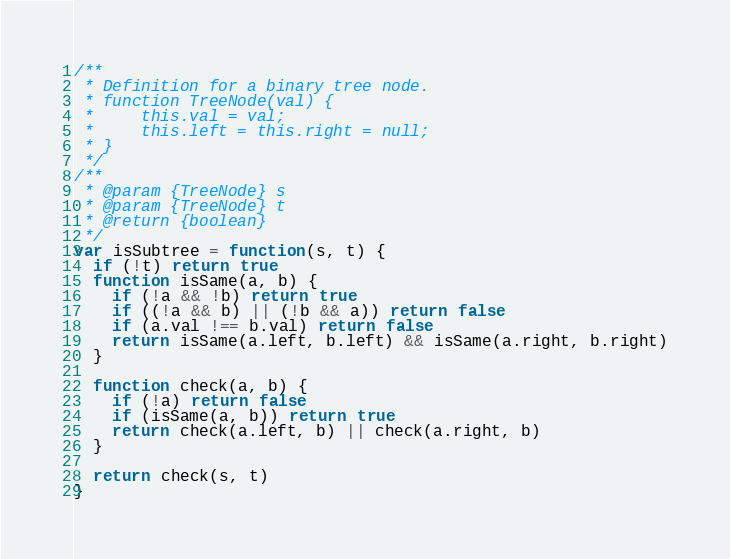Convert code to text. <code><loc_0><loc_0><loc_500><loc_500><_JavaScript_>/**
 * Definition for a binary tree node.
 * function TreeNode(val) {
 *     this.val = val;
 *     this.left = this.right = null;
 * }
 */
/**
 * @param {TreeNode} s
 * @param {TreeNode} t
 * @return {boolean}
 */
var isSubtree = function(s, t) {
  if (!t) return true
  function isSame(a, b) {
    if (!a && !b) return true
    if ((!a && b) || (!b && a)) return false
    if (a.val !== b.val) return false
    return isSame(a.left, b.left) && isSame(a.right, b.right)
  }

  function check(a, b) {
    if (!a) return false
    if (isSame(a, b)) return true
    return check(a.left, b) || check(a.right, b)
  }

  return check(s, t)
}
</code> 